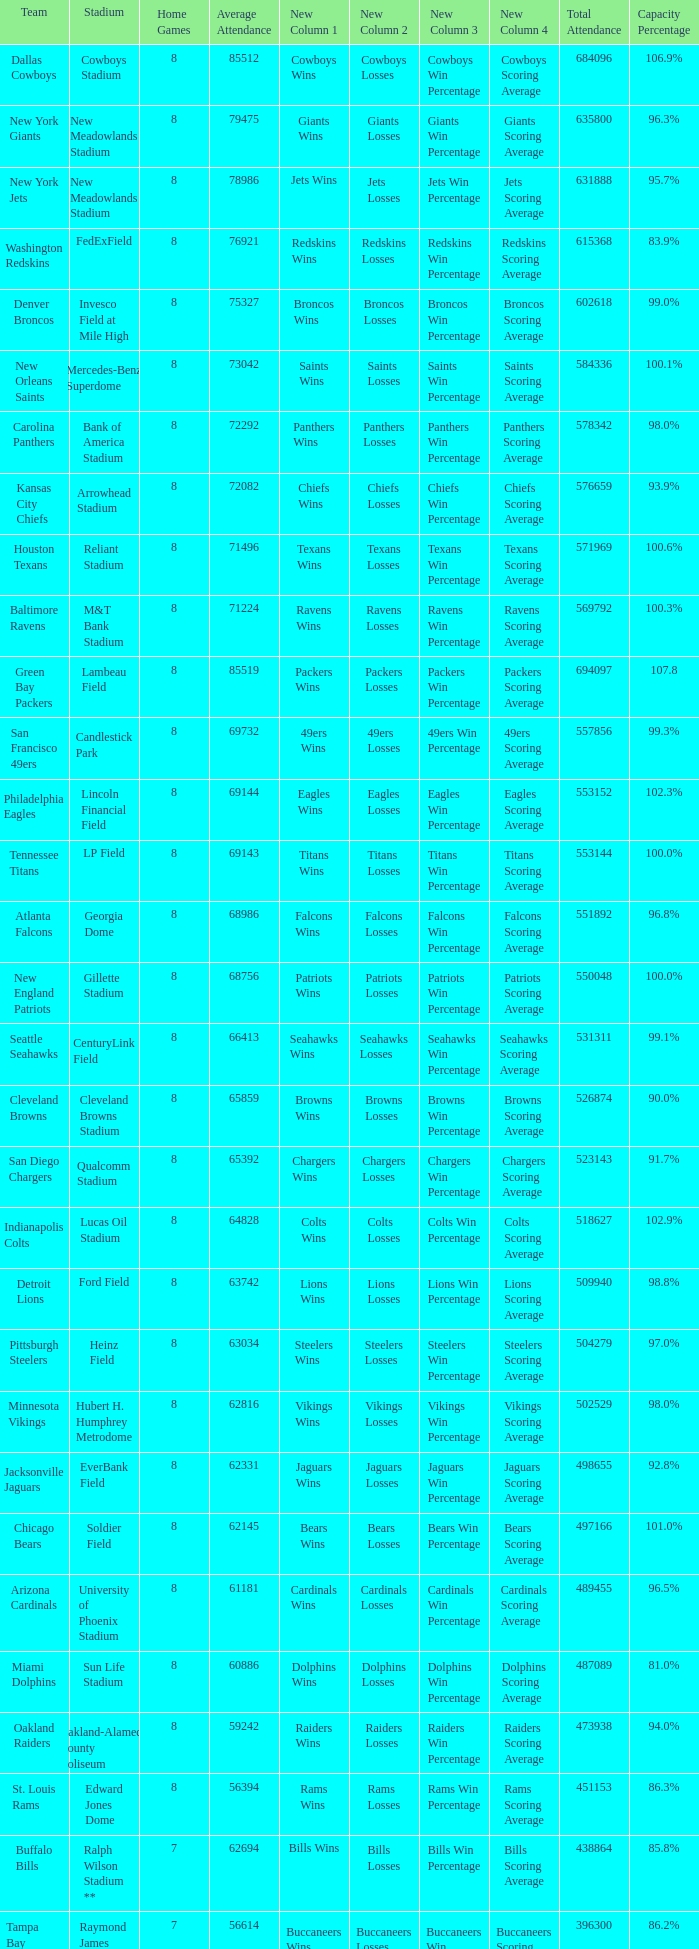What is the name of the team when the stadium is listed as Edward Jones Dome? St. Louis Rams. 